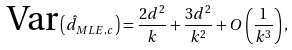Convert formula to latex. <formula><loc_0><loc_0><loc_500><loc_500>\text {Var} \left ( \hat { d } _ { M L E , c } \right ) = \frac { 2 d ^ { 2 } } { k } + \frac { 3 d ^ { 2 } } { k ^ { 2 } } + O \left ( \frac { 1 } { k ^ { 3 } } \right ) ,</formula> 